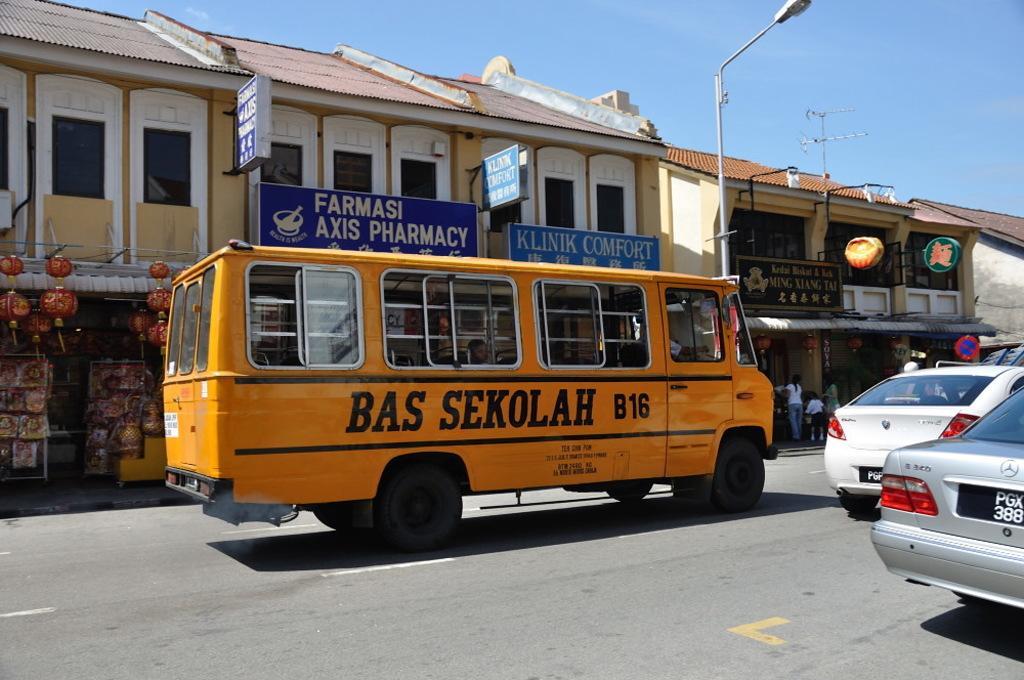Please provide a concise description of this image. In this picture we can see vehicles on the road, name boards, light pole, sign board, some objects, buildings with windows, some people are on the footpath and in the background we can see the sky. 